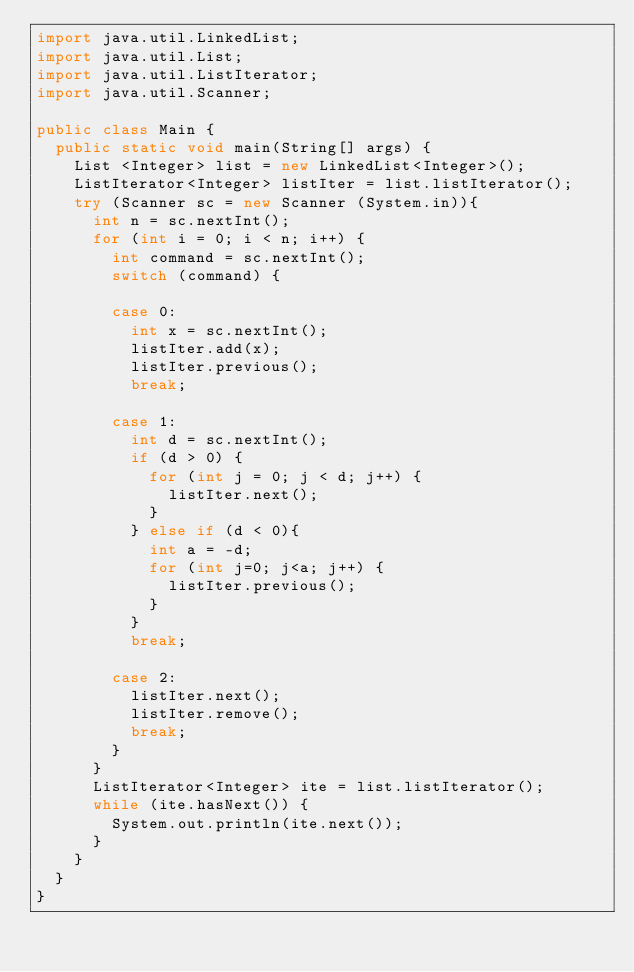Convert code to text. <code><loc_0><loc_0><loc_500><loc_500><_Java_>import java.util.LinkedList;
import java.util.List;
import java.util.ListIterator;
import java.util.Scanner;

public class Main {
	public static void main(String[] args) {
		List <Integer> list = new LinkedList<Integer>();
		ListIterator<Integer> listIter = list.listIterator();
		try (Scanner sc = new Scanner (System.in)){
			int n = sc.nextInt();
			for (int i = 0; i < n; i++) {
				int command = sc.nextInt();
				switch (command) {

				case 0:
					int x = sc.nextInt();
					listIter.add(x);
					listIter.previous();
					break;

				case 1:
					int d = sc.nextInt();
					if (d > 0) {
						for (int j = 0; j < d; j++) {
							listIter.next();  
						}
					} else if (d < 0){
						int a = -d; 
						for (int j=0; j<a; j++) {
							listIter.previous(); 
						}
					}
					break;
					
				case 2:
					listIter.next();  
					listIter.remove();
					break;
				}
			}
			ListIterator<Integer> ite = list.listIterator();			
			while (ite.hasNext()) {
				System.out.println(ite.next());  
			}
		}
	}
}


</code> 